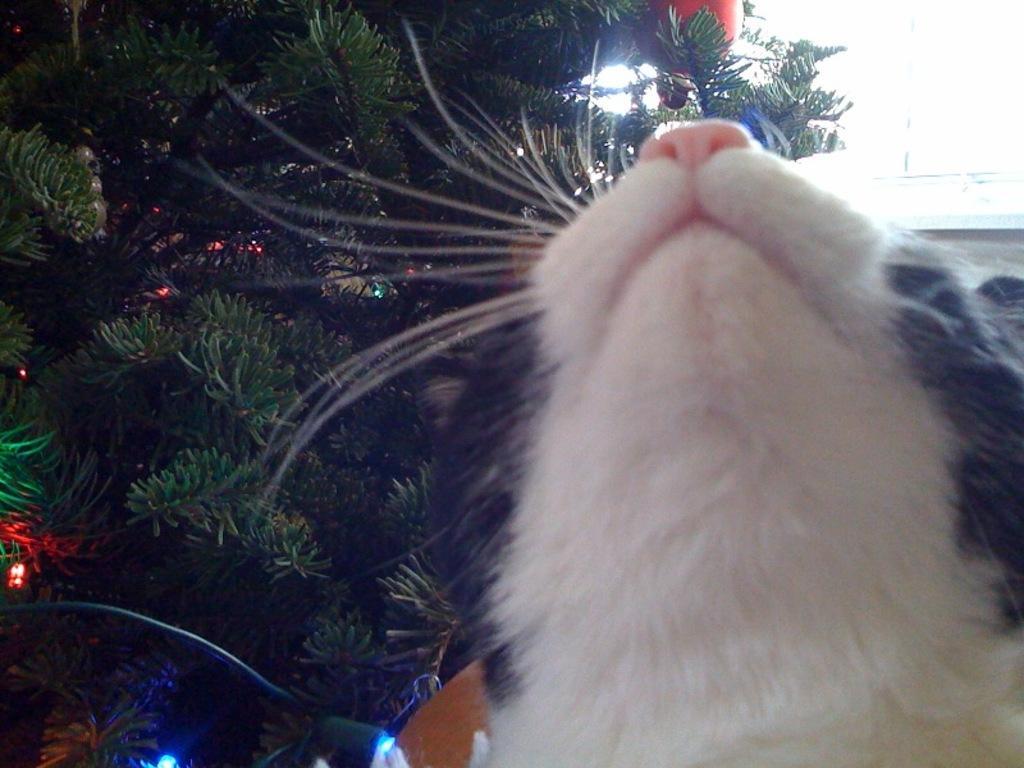In one or two sentences, can you explain what this image depicts? In this image we can see a cat, here are the trees, here is the light, at above here is the sky. 